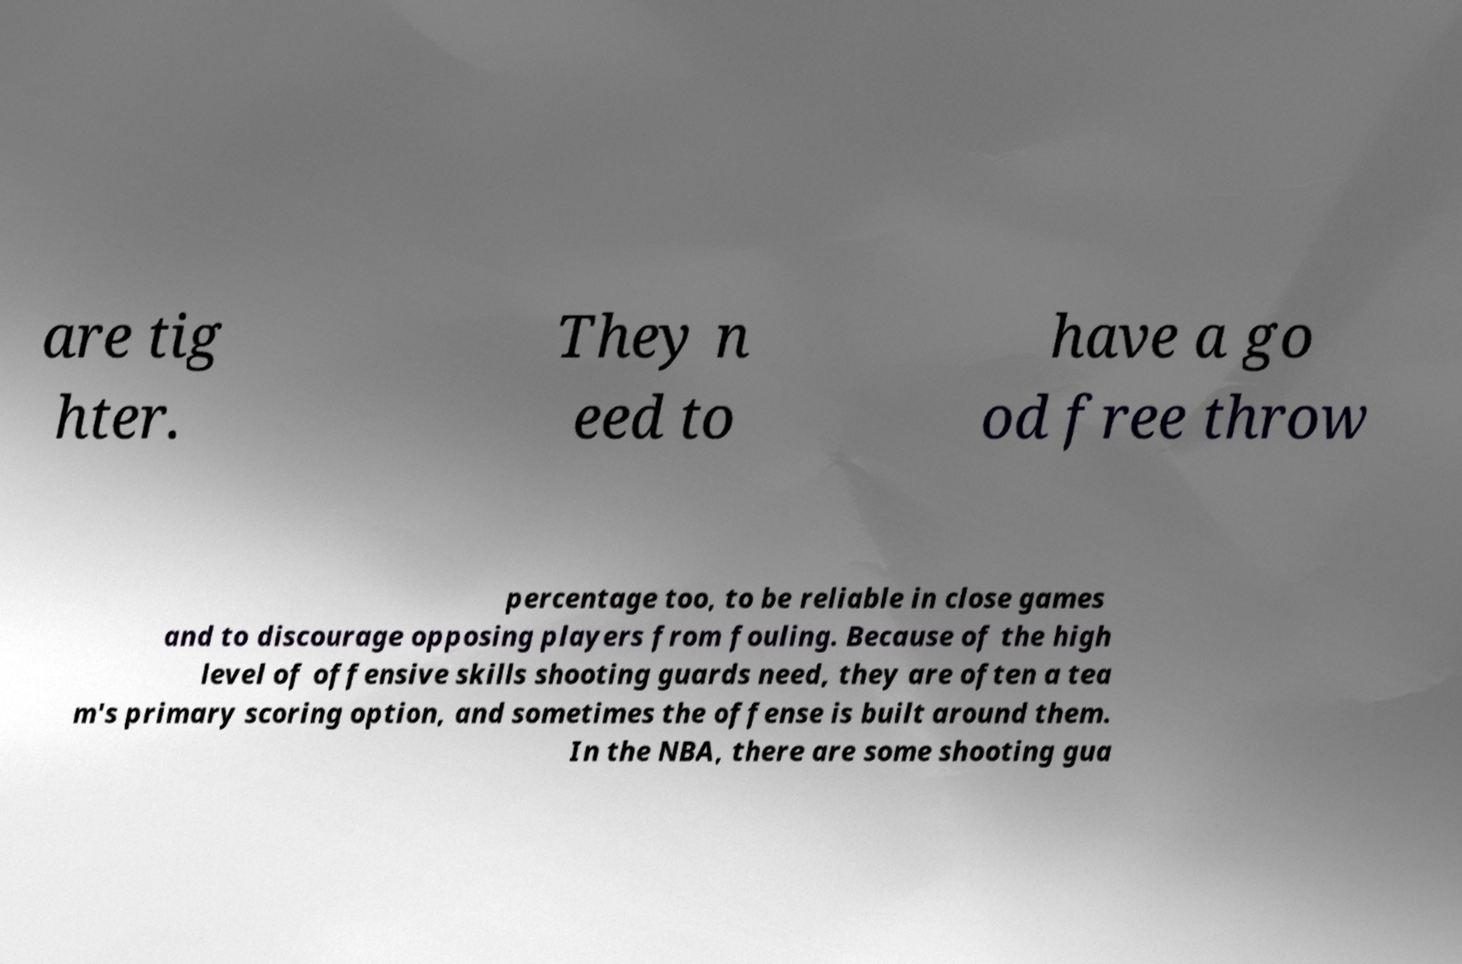For documentation purposes, I need the text within this image transcribed. Could you provide that? are tig hter. They n eed to have a go od free throw percentage too, to be reliable in close games and to discourage opposing players from fouling. Because of the high level of offensive skills shooting guards need, they are often a tea m's primary scoring option, and sometimes the offense is built around them. In the NBA, there are some shooting gua 